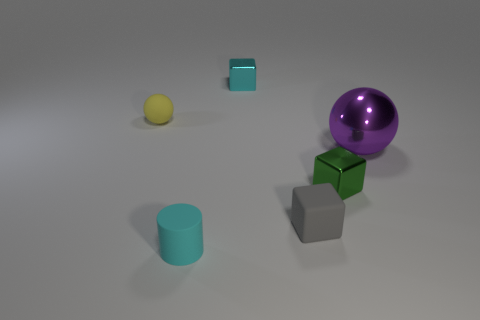Subtract all brown cylinders. Subtract all yellow balls. How many cylinders are left? 1 Add 2 big brown rubber cubes. How many objects exist? 8 Subtract all cylinders. How many objects are left? 5 Subtract all big yellow cylinders. Subtract all metallic balls. How many objects are left? 5 Add 3 gray matte cubes. How many gray matte cubes are left? 4 Add 6 red shiny cubes. How many red shiny cubes exist? 6 Subtract 0 red blocks. How many objects are left? 6 